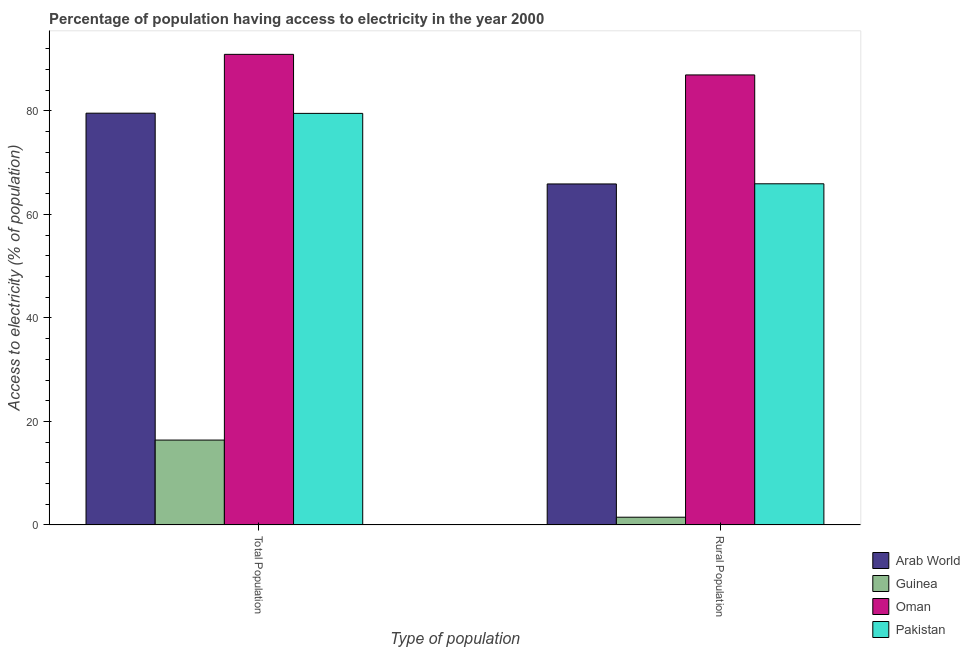How many groups of bars are there?
Keep it short and to the point. 2. Are the number of bars per tick equal to the number of legend labels?
Give a very brief answer. Yes. How many bars are there on the 1st tick from the left?
Your answer should be very brief. 4. How many bars are there on the 2nd tick from the right?
Keep it short and to the point. 4. What is the label of the 2nd group of bars from the left?
Keep it short and to the point. Rural Population. What is the percentage of population having access to electricity in Guinea?
Offer a terse response. 16.4. Across all countries, what is the maximum percentage of population having access to electricity?
Make the answer very short. 90.9. Across all countries, what is the minimum percentage of rural population having access to electricity?
Ensure brevity in your answer.  1.5. In which country was the percentage of rural population having access to electricity maximum?
Your answer should be very brief. Oman. In which country was the percentage of rural population having access to electricity minimum?
Provide a short and direct response. Guinea. What is the total percentage of population having access to electricity in the graph?
Your response must be concise. 266.34. What is the difference between the percentage of population having access to electricity in Guinea and that in Pakistan?
Ensure brevity in your answer.  -63.1. What is the difference between the percentage of population having access to electricity in Arab World and the percentage of rural population having access to electricity in Pakistan?
Your response must be concise. 13.64. What is the average percentage of rural population having access to electricity per country?
Provide a short and direct response. 55.05. What is the difference between the percentage of rural population having access to electricity and percentage of population having access to electricity in Pakistan?
Your answer should be compact. -13.6. In how many countries, is the percentage of population having access to electricity greater than 88 %?
Your response must be concise. 1. What is the ratio of the percentage of rural population having access to electricity in Arab World to that in Guinea?
Give a very brief answer. 43.91. What does the 1st bar from the left in Rural Population represents?
Your answer should be compact. Arab World. What does the 4th bar from the right in Rural Population represents?
Give a very brief answer. Arab World. How many bars are there?
Provide a short and direct response. 8. What is the difference between two consecutive major ticks on the Y-axis?
Offer a very short reply. 20. Does the graph contain any zero values?
Keep it short and to the point. No. Does the graph contain grids?
Your answer should be compact. No. Where does the legend appear in the graph?
Ensure brevity in your answer.  Bottom right. How are the legend labels stacked?
Make the answer very short. Vertical. What is the title of the graph?
Keep it short and to the point. Percentage of population having access to electricity in the year 2000. Does "Kenya" appear as one of the legend labels in the graph?
Your answer should be very brief. No. What is the label or title of the X-axis?
Provide a short and direct response. Type of population. What is the label or title of the Y-axis?
Provide a succinct answer. Access to electricity (% of population). What is the Access to electricity (% of population) of Arab World in Total Population?
Your answer should be compact. 79.54. What is the Access to electricity (% of population) of Oman in Total Population?
Make the answer very short. 90.9. What is the Access to electricity (% of population) in Pakistan in Total Population?
Provide a succinct answer. 79.5. What is the Access to electricity (% of population) in Arab World in Rural Population?
Your response must be concise. 65.87. What is the Access to electricity (% of population) of Guinea in Rural Population?
Offer a terse response. 1.5. What is the Access to electricity (% of population) of Oman in Rural Population?
Give a very brief answer. 86.93. What is the Access to electricity (% of population) in Pakistan in Rural Population?
Your response must be concise. 65.9. Across all Type of population, what is the maximum Access to electricity (% of population) of Arab World?
Offer a terse response. 79.54. Across all Type of population, what is the maximum Access to electricity (% of population) in Guinea?
Your answer should be compact. 16.4. Across all Type of population, what is the maximum Access to electricity (% of population) of Oman?
Give a very brief answer. 90.9. Across all Type of population, what is the maximum Access to electricity (% of population) in Pakistan?
Ensure brevity in your answer.  79.5. Across all Type of population, what is the minimum Access to electricity (% of population) of Arab World?
Provide a short and direct response. 65.87. Across all Type of population, what is the minimum Access to electricity (% of population) in Oman?
Ensure brevity in your answer.  86.93. Across all Type of population, what is the minimum Access to electricity (% of population) in Pakistan?
Your answer should be very brief. 65.9. What is the total Access to electricity (% of population) of Arab World in the graph?
Offer a very short reply. 145.41. What is the total Access to electricity (% of population) of Oman in the graph?
Provide a short and direct response. 177.82. What is the total Access to electricity (% of population) in Pakistan in the graph?
Give a very brief answer. 145.4. What is the difference between the Access to electricity (% of population) of Arab World in Total Population and that in Rural Population?
Provide a succinct answer. 13.67. What is the difference between the Access to electricity (% of population) of Guinea in Total Population and that in Rural Population?
Your answer should be compact. 14.9. What is the difference between the Access to electricity (% of population) in Oman in Total Population and that in Rural Population?
Provide a succinct answer. 3.97. What is the difference between the Access to electricity (% of population) of Pakistan in Total Population and that in Rural Population?
Provide a short and direct response. 13.6. What is the difference between the Access to electricity (% of population) of Arab World in Total Population and the Access to electricity (% of population) of Guinea in Rural Population?
Keep it short and to the point. 78.04. What is the difference between the Access to electricity (% of population) of Arab World in Total Population and the Access to electricity (% of population) of Oman in Rural Population?
Keep it short and to the point. -7.39. What is the difference between the Access to electricity (% of population) in Arab World in Total Population and the Access to electricity (% of population) in Pakistan in Rural Population?
Offer a very short reply. 13.64. What is the difference between the Access to electricity (% of population) in Guinea in Total Population and the Access to electricity (% of population) in Oman in Rural Population?
Ensure brevity in your answer.  -70.53. What is the difference between the Access to electricity (% of population) of Guinea in Total Population and the Access to electricity (% of population) of Pakistan in Rural Population?
Give a very brief answer. -49.5. What is the difference between the Access to electricity (% of population) in Oman in Total Population and the Access to electricity (% of population) in Pakistan in Rural Population?
Keep it short and to the point. 25. What is the average Access to electricity (% of population) of Arab World per Type of population?
Keep it short and to the point. 72.7. What is the average Access to electricity (% of population) of Guinea per Type of population?
Your response must be concise. 8.95. What is the average Access to electricity (% of population) of Oman per Type of population?
Give a very brief answer. 88.91. What is the average Access to electricity (% of population) of Pakistan per Type of population?
Your answer should be very brief. 72.7. What is the difference between the Access to electricity (% of population) of Arab World and Access to electricity (% of population) of Guinea in Total Population?
Offer a very short reply. 63.14. What is the difference between the Access to electricity (% of population) in Arab World and Access to electricity (% of population) in Oman in Total Population?
Your response must be concise. -11.36. What is the difference between the Access to electricity (% of population) in Arab World and Access to electricity (% of population) in Pakistan in Total Population?
Keep it short and to the point. 0.04. What is the difference between the Access to electricity (% of population) of Guinea and Access to electricity (% of population) of Oman in Total Population?
Provide a succinct answer. -74.5. What is the difference between the Access to electricity (% of population) in Guinea and Access to electricity (% of population) in Pakistan in Total Population?
Keep it short and to the point. -63.1. What is the difference between the Access to electricity (% of population) of Oman and Access to electricity (% of population) of Pakistan in Total Population?
Provide a short and direct response. 11.4. What is the difference between the Access to electricity (% of population) in Arab World and Access to electricity (% of population) in Guinea in Rural Population?
Keep it short and to the point. 64.37. What is the difference between the Access to electricity (% of population) of Arab World and Access to electricity (% of population) of Oman in Rural Population?
Offer a very short reply. -21.06. What is the difference between the Access to electricity (% of population) in Arab World and Access to electricity (% of population) in Pakistan in Rural Population?
Give a very brief answer. -0.03. What is the difference between the Access to electricity (% of population) of Guinea and Access to electricity (% of population) of Oman in Rural Population?
Give a very brief answer. -85.43. What is the difference between the Access to electricity (% of population) in Guinea and Access to electricity (% of population) in Pakistan in Rural Population?
Provide a short and direct response. -64.4. What is the difference between the Access to electricity (% of population) in Oman and Access to electricity (% of population) in Pakistan in Rural Population?
Your answer should be compact. 21.03. What is the ratio of the Access to electricity (% of population) of Arab World in Total Population to that in Rural Population?
Provide a succinct answer. 1.21. What is the ratio of the Access to electricity (% of population) of Guinea in Total Population to that in Rural Population?
Ensure brevity in your answer.  10.93. What is the ratio of the Access to electricity (% of population) in Oman in Total Population to that in Rural Population?
Your answer should be very brief. 1.05. What is the ratio of the Access to electricity (% of population) in Pakistan in Total Population to that in Rural Population?
Offer a terse response. 1.21. What is the difference between the highest and the second highest Access to electricity (% of population) of Arab World?
Provide a succinct answer. 13.67. What is the difference between the highest and the second highest Access to electricity (% of population) of Guinea?
Your answer should be compact. 14.9. What is the difference between the highest and the second highest Access to electricity (% of population) in Oman?
Your response must be concise. 3.97. What is the difference between the highest and the second highest Access to electricity (% of population) in Pakistan?
Your response must be concise. 13.6. What is the difference between the highest and the lowest Access to electricity (% of population) in Arab World?
Your response must be concise. 13.67. What is the difference between the highest and the lowest Access to electricity (% of population) of Oman?
Your answer should be compact. 3.97. What is the difference between the highest and the lowest Access to electricity (% of population) in Pakistan?
Your answer should be very brief. 13.6. 